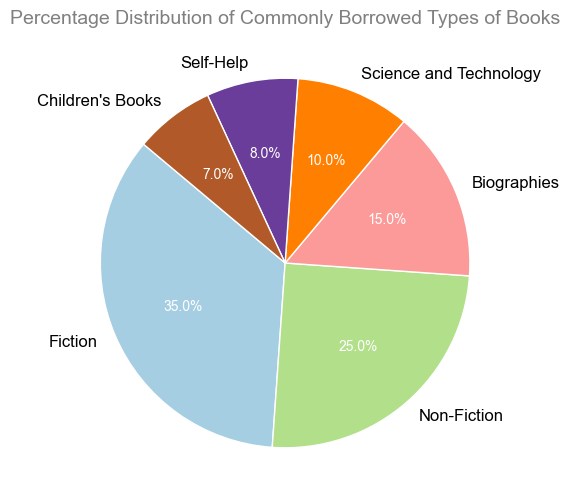What percentage of borrowed books are Fiction? Look at the segment labeled "Fiction" and note the percentage value given in the chart.
Answer: 35% Which category has the smallest percentage of borrowed books? Identify the segment with the smallest numerical value.
Answer: Children's Books Compare the percentage of Fiction and Non-Fiction books. Which is higher? Locate the segments for Fiction and Non-Fiction and compare their percentage values.
Answer: Fiction What is the total percentage of Biographies and Self-Help books combined? Add the percentage values for Biographies and Self-Help segments: 15% + 8%.
Answer: 23% Which category falls between Non-Fiction and Children's Books in terms of percentage? Compare the percentage values and find the category that falls between 25% (Non-Fiction) and 7% (Children's Books).
Answer: Biographies How much more popular are Fiction books compared to Science and Technology books? Subtract the percentage value of Science and Technology from the value of Fiction: 35% - 10%.
Answer: 25% Which have a greater combined percentage, Non-Fiction and Biographies or Science and Technology and Children's Books? Add the percentage values for Non-Fiction and Biographies: 25% + 15% = 40%. Then add the values for Science and Technology and Children's Books: 10% + 7% = 17%. Compare the two sums.
Answer: Non-Fiction and Biographies What color represents the Children's Books category? Identify the segment labeled "Children's Books" and describe its visual color attribute.
Answer: Light brown (or whatever color used in the plot) Out of the six categories, how many have a percentage lower than 15%? Identify categories with percentage values less than 15%: Science and Technology (10%), Self-Help (8%), and Children's Books (7%).
Answer: 3 categories If you combine Categories with more than 10% percentage, what is their total? Identify the categories with more than 10%: Fiction (35%), Non-Fiction (25%), and Biographies (15%). Add these values: 35% + 25% + 15%.
Answer: 75% 